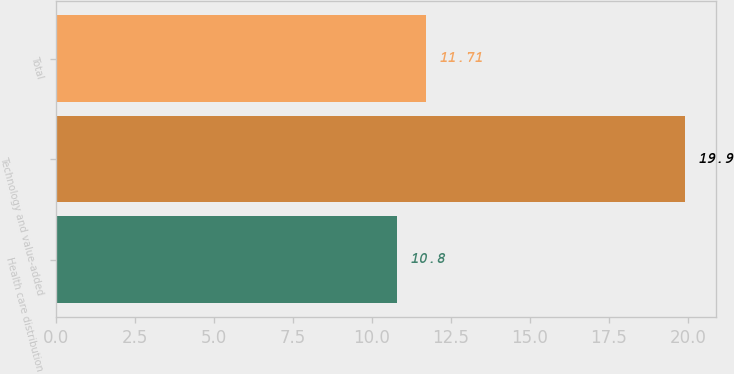Convert chart to OTSL. <chart><loc_0><loc_0><loc_500><loc_500><bar_chart><fcel>Health care distribution<fcel>Technology and value-added<fcel>Total<nl><fcel>10.8<fcel>19.9<fcel>11.71<nl></chart> 